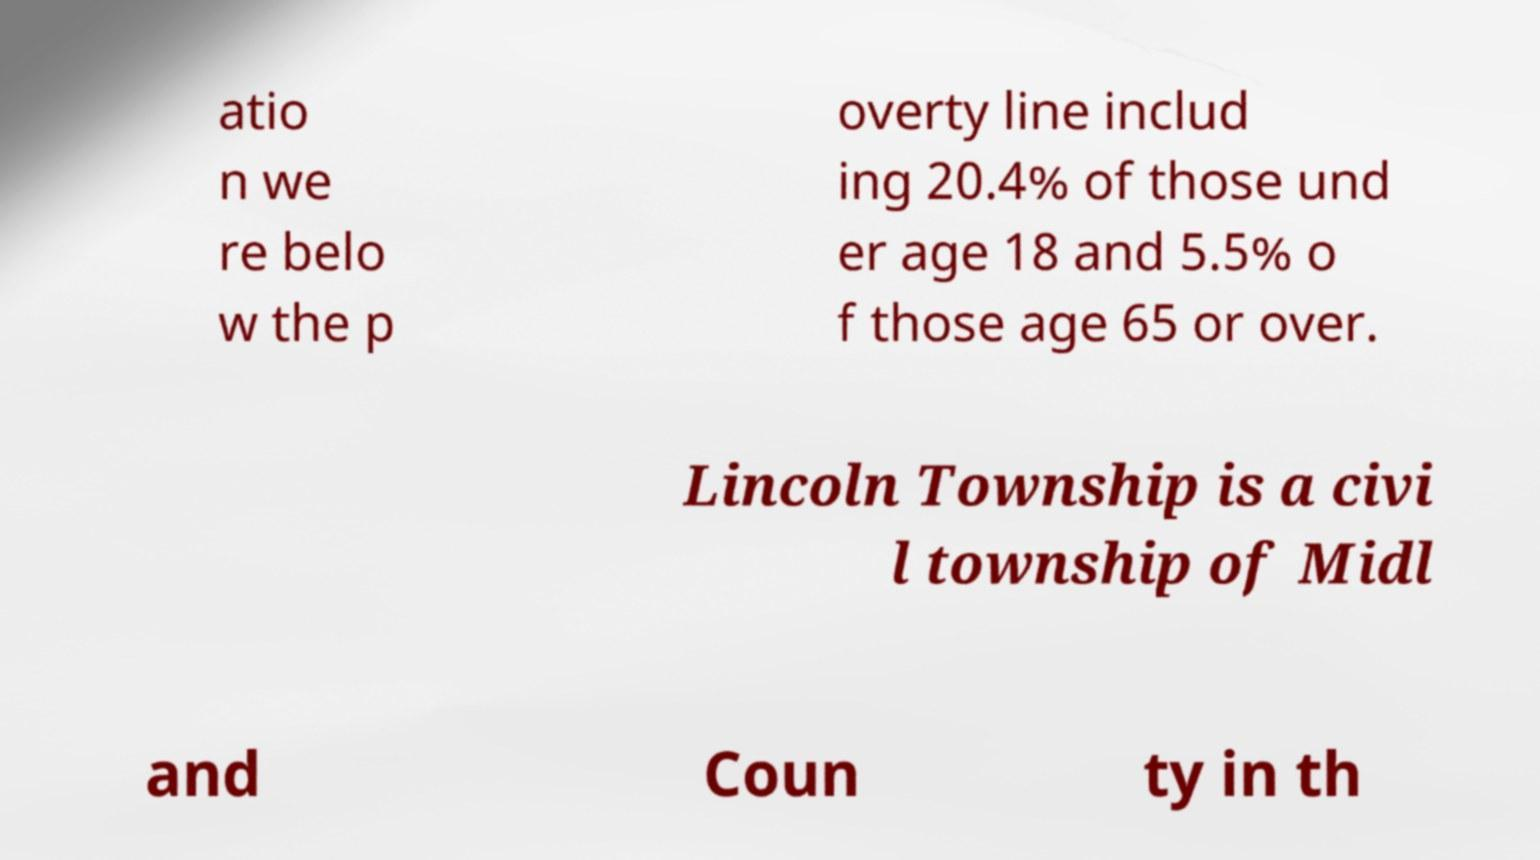Could you assist in decoding the text presented in this image and type it out clearly? atio n we re belo w the p overty line includ ing 20.4% of those und er age 18 and 5.5% o f those age 65 or over. Lincoln Township is a civi l township of Midl and Coun ty in th 